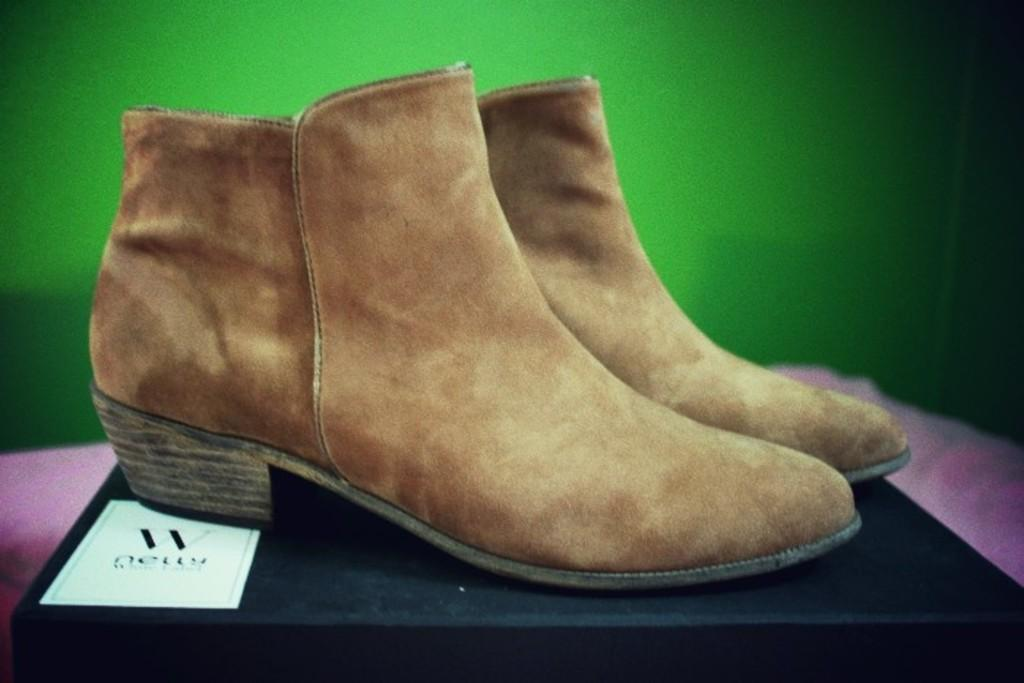What objects are in the foreground of the picture? There are shoes in the foreground of the picture. What is the shoes resting on? The shoes are on a box. What color is the background of the image? A: The background of the image is green. What type of toy can be seen in the background of the image? There is no toy present in the image; the background is green. What color is the underwear in the image? There is no underwear present in the image. 